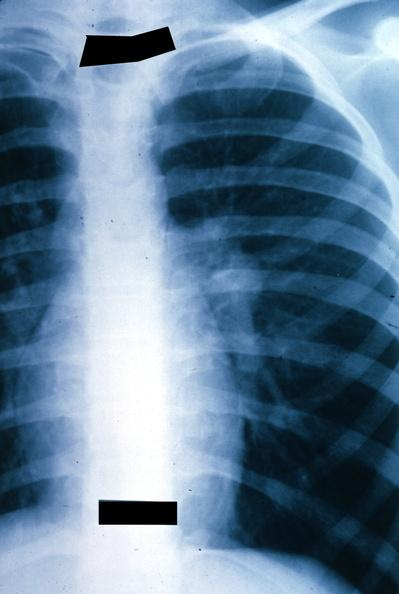s lung present?
Answer the question using a single word or phrase. Yes 